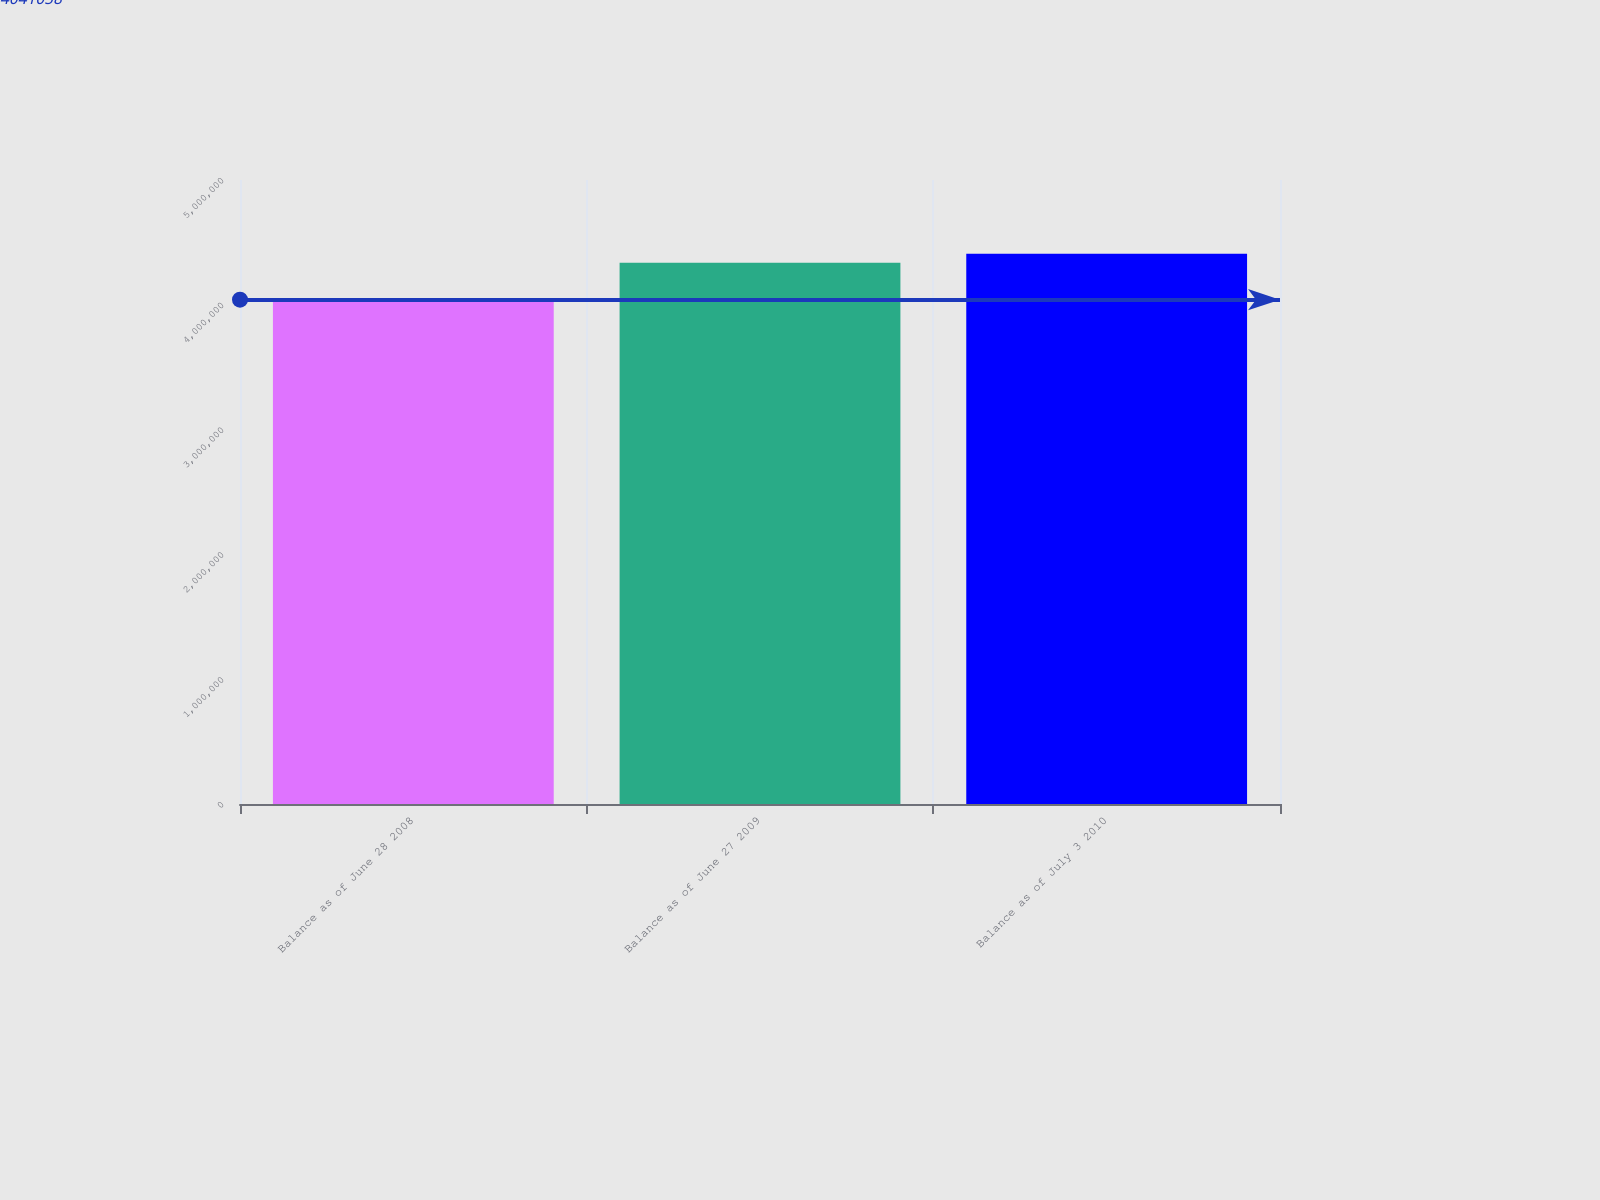Convert chart to OTSL. <chart><loc_0><loc_0><loc_500><loc_500><bar_chart><fcel>Balance as of June 28 2008<fcel>Balance as of June 27 2009<fcel>Balance as of July 3 2010<nl><fcel>4.04106e+06<fcel>4.33773e+06<fcel>4.40837e+06<nl></chart> 